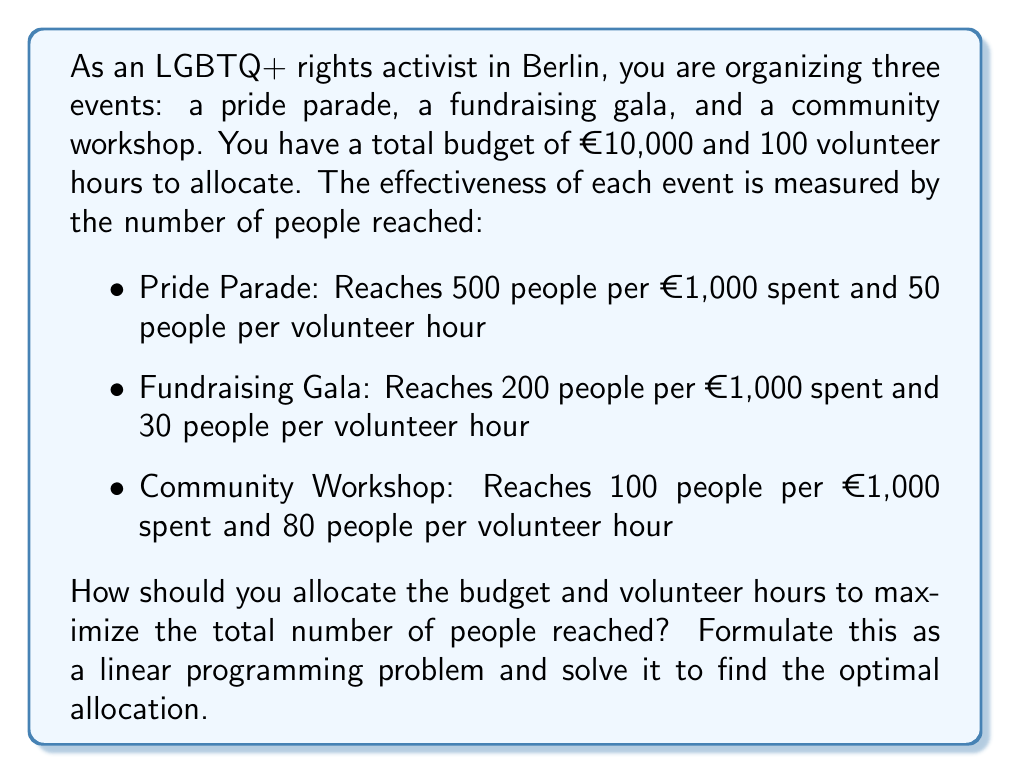Provide a solution to this math problem. Let's approach this step-by-step:

1) Define variables:
   Let $x_1$, $x_2$, and $x_3$ be the amount of money (in thousands of euros) allocated to the Pride Parade, Fundraising Gala, and Community Workshop respectively.
   Let $y_1$, $y_2$, and $y_3$ be the number of volunteer hours allocated to each event respectively.

2) Objective function:
   We want to maximize the total number of people reached:
   $$\text{Maximize } Z = 500x_1 + 50y_1 + 200x_2 + 30y_2 + 100x_3 + 80y_3$$

3) Constraints:
   Budget constraint: $x_1 + x_2 + x_3 \leq 10$
   Volunteer hours constraint: $y_1 + y_2 + y_3 \leq 100$
   Non-negativity: $x_1, x_2, x_3, y_1, y_2, y_3 \geq 0$

4) Solve using the simplex method or linear programming software:

   The optimal solution is:
   $x_1 = 10, x_2 = 0, x_3 = 0$
   $y_1 = 0, y_2 = 0, y_3 = 100$

5) Interpretation:
   Allocate all €10,000 to the Pride Parade and all 100 volunteer hours to the Community Workshop.

6) Calculate the maximum number of people reached:
   $Z = 500(10) + 50(0) + 200(0) + 30(0) + 100(0) + 80(100) = 5,000 + 8,000 = 13,000$
Answer: The optimal allocation is to spend the entire €10,000 budget on the Pride Parade and allocate all 100 volunteer hours to the Community Workshop. This will reach a maximum of 13,000 people. 